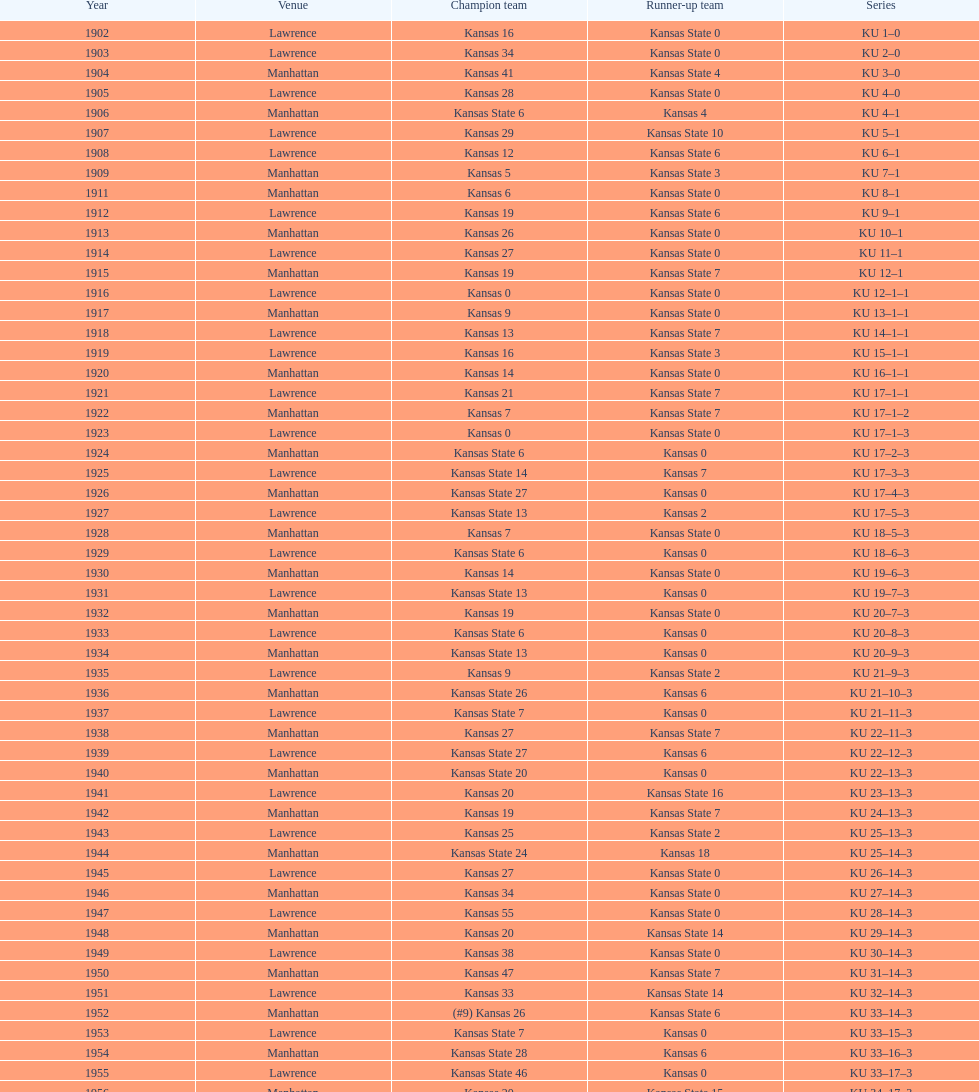What was the count of victories kansas state had in manhattan? 8. 